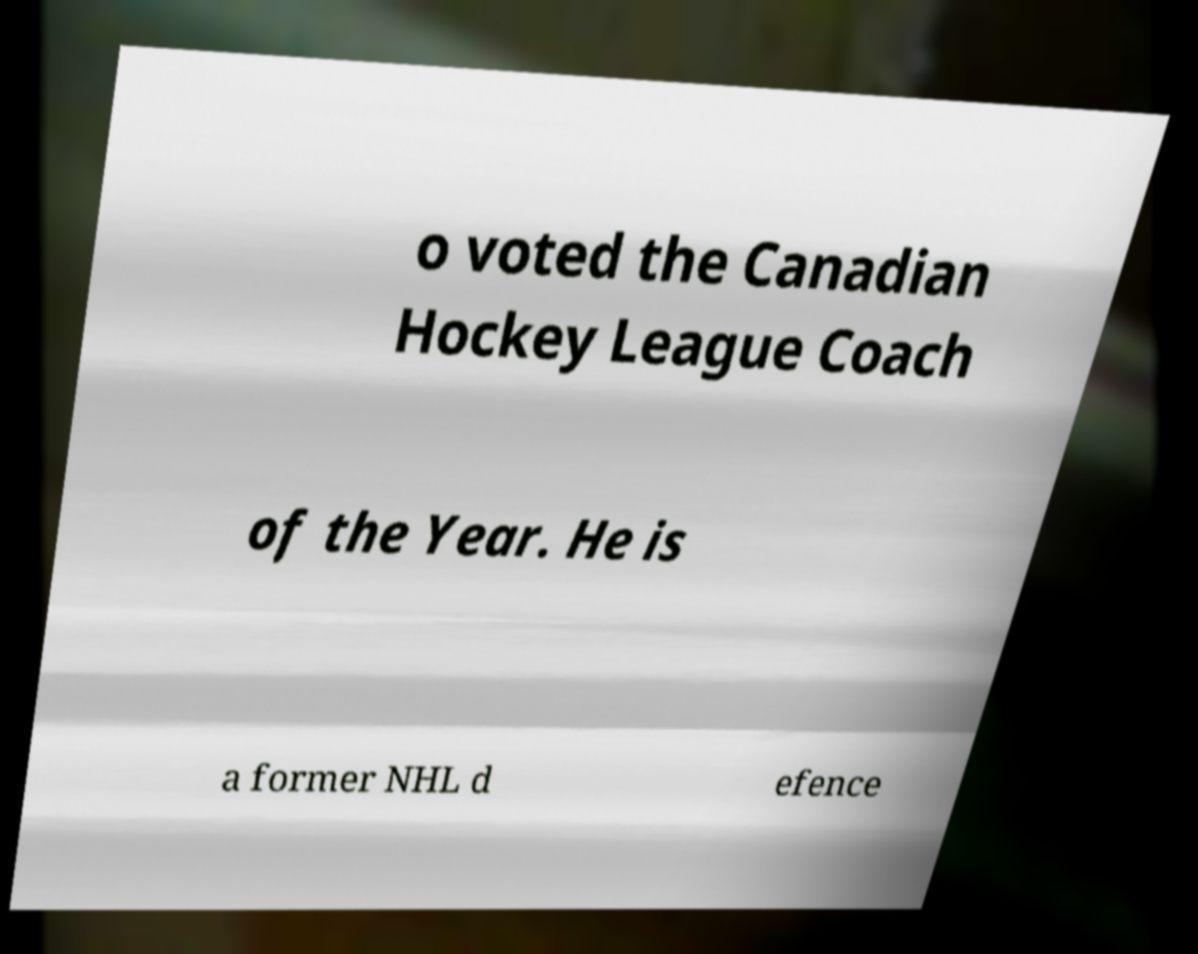There's text embedded in this image that I need extracted. Can you transcribe it verbatim? o voted the Canadian Hockey League Coach of the Year. He is a former NHL d efence 